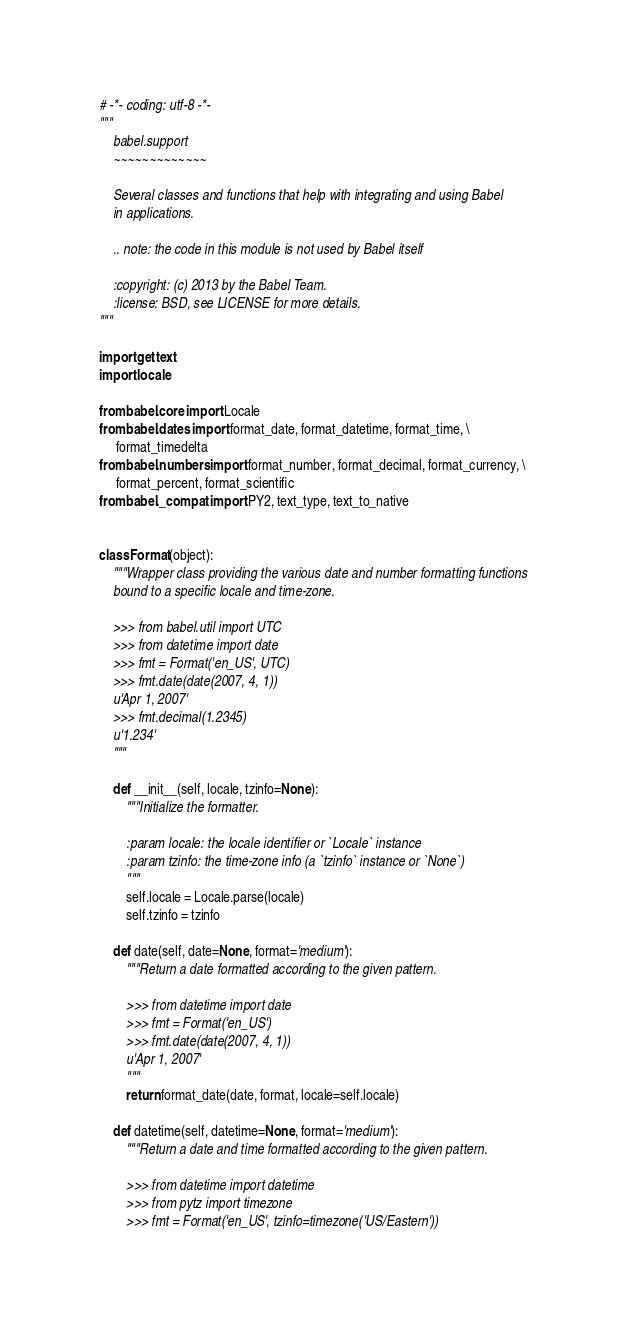<code> <loc_0><loc_0><loc_500><loc_500><_Python_># -*- coding: utf-8 -*-
"""
    babel.support
    ~~~~~~~~~~~~~

    Several classes and functions that help with integrating and using Babel
    in applications.

    .. note: the code in this module is not used by Babel itself

    :copyright: (c) 2013 by the Babel Team.
    :license: BSD, see LICENSE for more details.
"""

import gettext
import locale

from babel.core import Locale
from babel.dates import format_date, format_datetime, format_time, \
     format_timedelta
from babel.numbers import format_number, format_decimal, format_currency, \
     format_percent, format_scientific
from babel._compat import PY2, text_type, text_to_native


class Format(object):
    """Wrapper class providing the various date and number formatting functions
    bound to a specific locale and time-zone.

    >>> from babel.util import UTC
    >>> from datetime import date
    >>> fmt = Format('en_US', UTC)
    >>> fmt.date(date(2007, 4, 1))
    u'Apr 1, 2007'
    >>> fmt.decimal(1.2345)
    u'1.234'
    """

    def __init__(self, locale, tzinfo=None):
        """Initialize the formatter.

        :param locale: the locale identifier or `Locale` instance
        :param tzinfo: the time-zone info (a `tzinfo` instance or `None`)
        """
        self.locale = Locale.parse(locale)
        self.tzinfo = tzinfo

    def date(self, date=None, format='medium'):
        """Return a date formatted according to the given pattern.

        >>> from datetime import date
        >>> fmt = Format('en_US')
        >>> fmt.date(date(2007, 4, 1))
        u'Apr 1, 2007'
        """
        return format_date(date, format, locale=self.locale)

    def datetime(self, datetime=None, format='medium'):
        """Return a date and time formatted according to the given pattern.

        >>> from datetime import datetime
        >>> from pytz import timezone
        >>> fmt = Format('en_US', tzinfo=timezone('US/Eastern'))</code> 